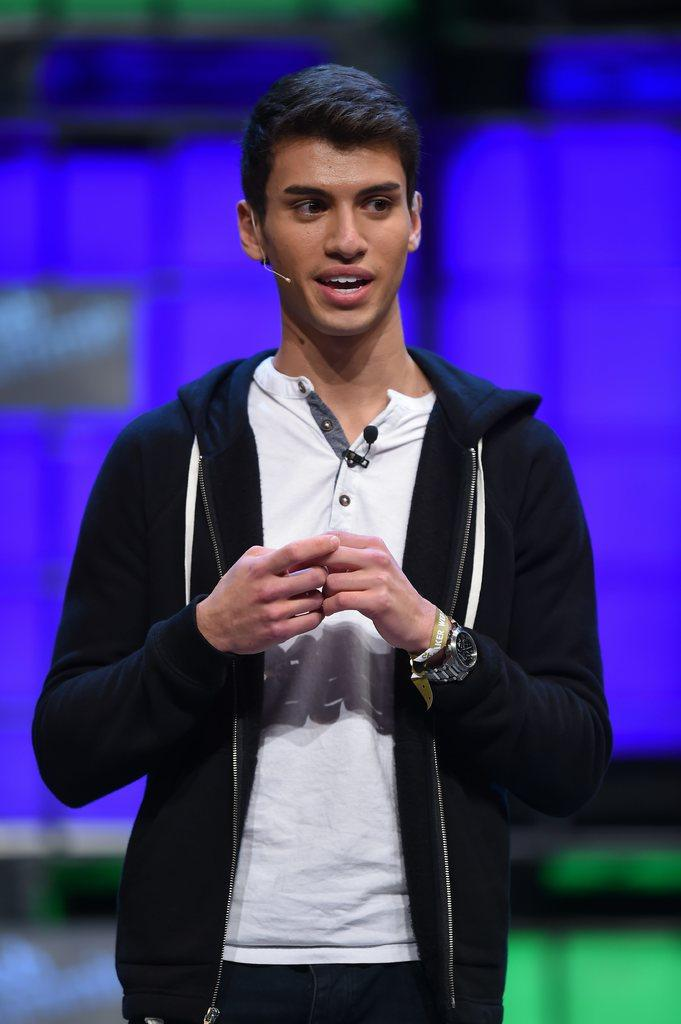What is the main subject of the image? There is a man in the image. What is the man wearing on his upper body? The man is wearing a white shirt and a black jacket. What accessory is the man wearing on his wrist? The man is wearing a watch. What is the man's posture in the image? The man is standing. What color is the screen visible in the background of the image? The screen in the background of the image is blue. What type of ink is being used by the birds in the image? There are no birds present in the image, so it is not possible to determine what type of ink they might be using. 